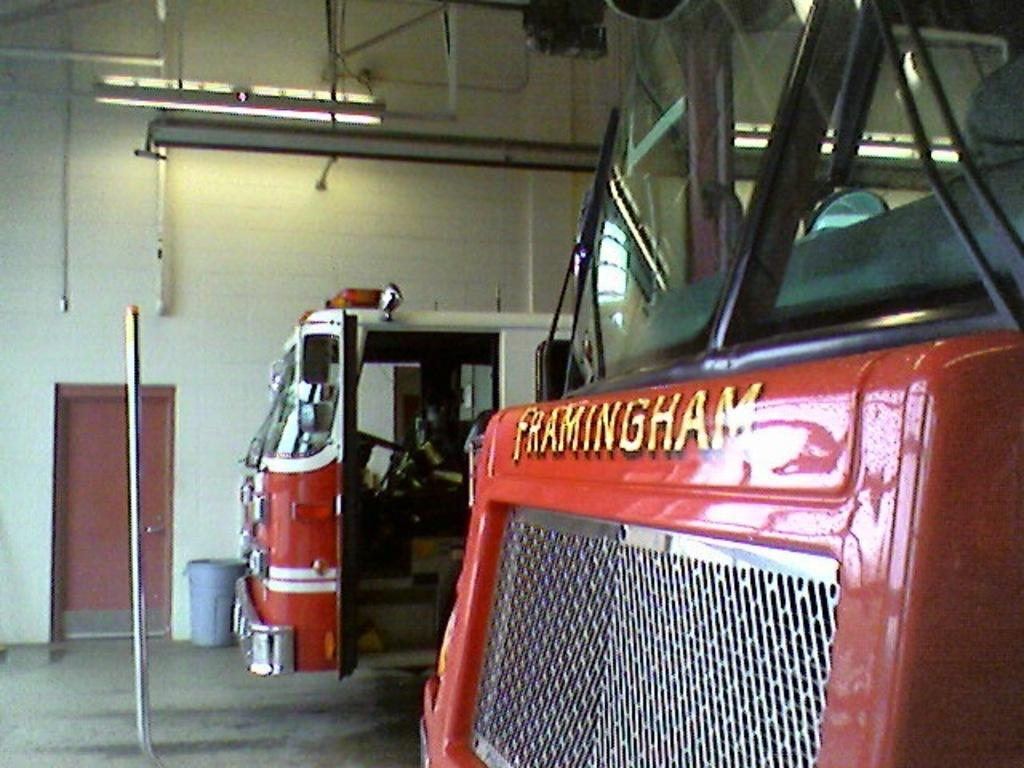What can be seen on the right side of the image? A: There are two vehicles on the right side of the image. What is visible in the background of the image? There is a wall in the background of the image. Where is the door located in the image? The door is on the left side of the image. Can you hear the bells ringing in the image? There is no mention of bells in the image, so it is not possible to hear them ringing. What observation can be made about the vehicles on the right side of the image? The provided facts do not mention any specific details about the vehicles, so no observation can be made beyond their presence in the image. 